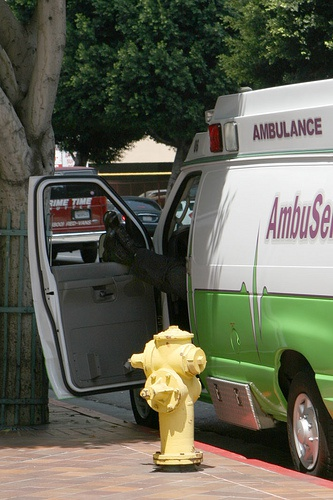Describe the objects in this image and their specific colors. I can see truck in black, lightgray, gray, and darkgray tones, fire hydrant in black, khaki, olive, and tan tones, and car in black, gray, purple, and darkblue tones in this image. 